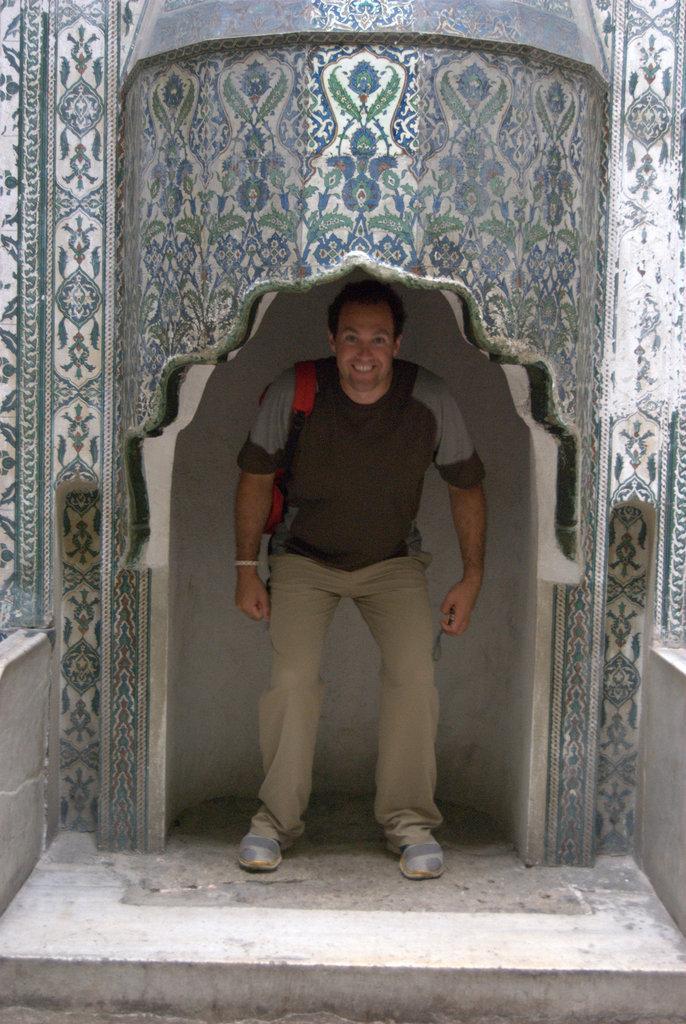Could you give a brief overview of what you see in this image? In the center of the image a man is standing and carrying a bag. At the top of the image an arch is present. At the bottom of the image ground is there. 